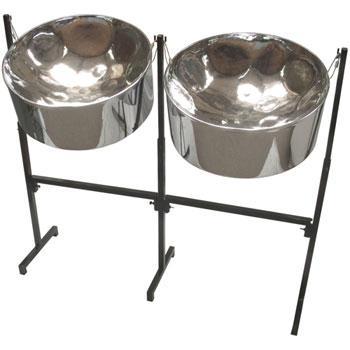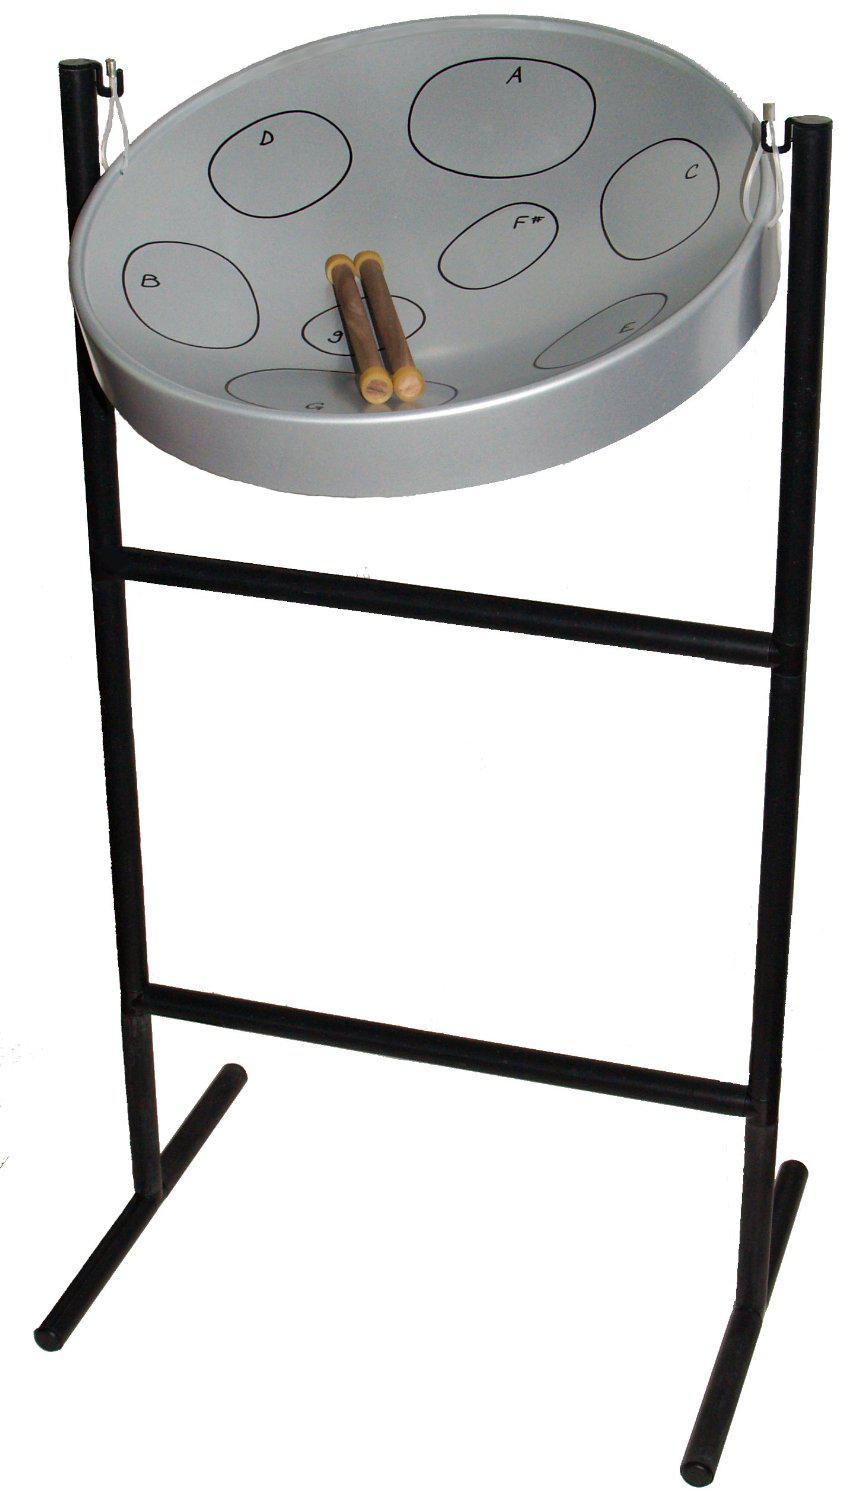The first image is the image on the left, the second image is the image on the right. Assess this claim about the two images: "There are 7 drums total.". Correct or not? Answer yes or no. No. The first image is the image on the left, the second image is the image on the right. Considering the images on both sides, is "Each image features a drum style with a concave top mounted on a pivoting stand, but one image contains one fewer bowl drum than the other image." valid? Answer yes or no. Yes. 